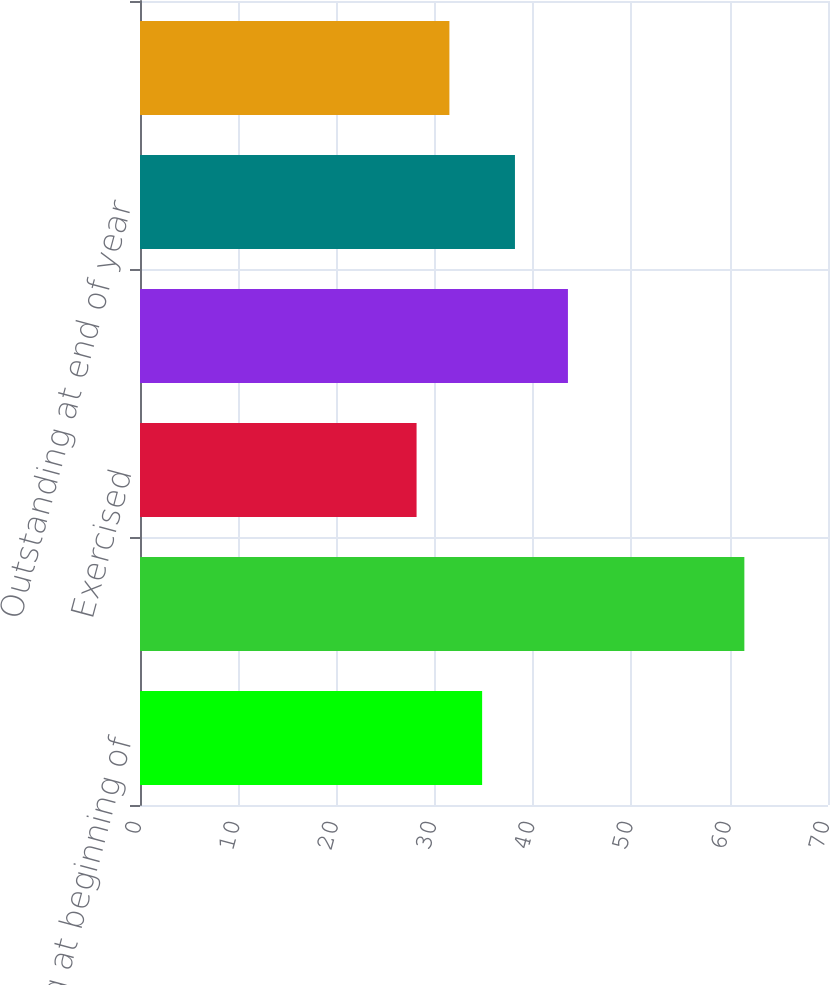Convert chart. <chart><loc_0><loc_0><loc_500><loc_500><bar_chart><fcel>Outstanding at beginning of<fcel>Granted<fcel>Exercised<fcel>Forfeited<fcel>Outstanding at end of year<fcel>Options exercisable at<nl><fcel>34.81<fcel>61.49<fcel>28.14<fcel>43.54<fcel>38.15<fcel>31.48<nl></chart> 